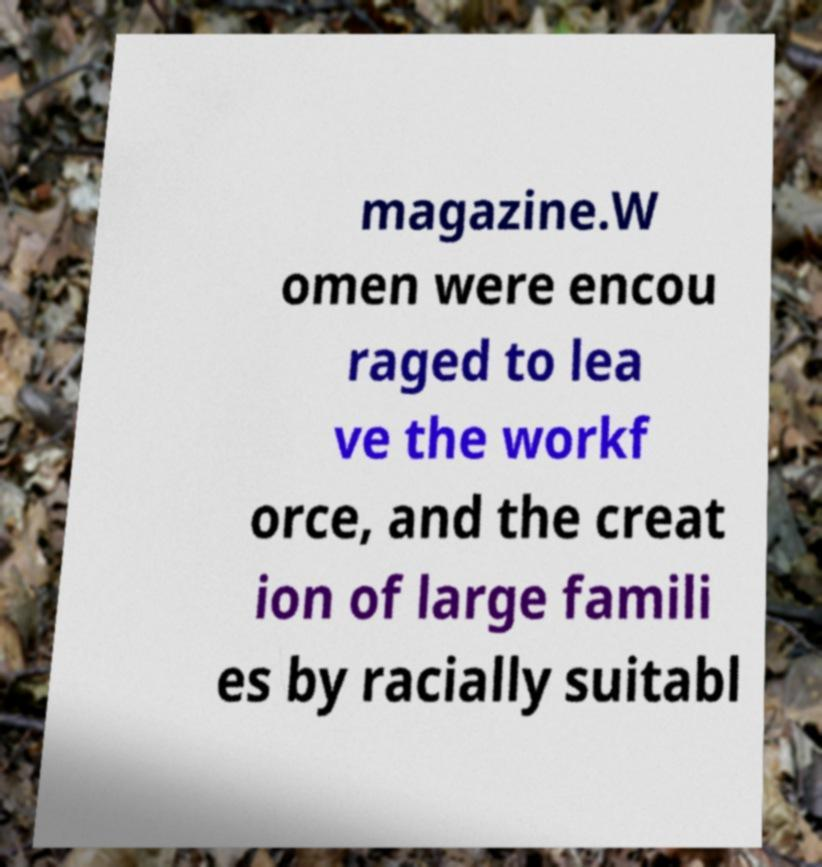Please identify and transcribe the text found in this image. magazine.W omen were encou raged to lea ve the workf orce, and the creat ion of large famili es by racially suitabl 